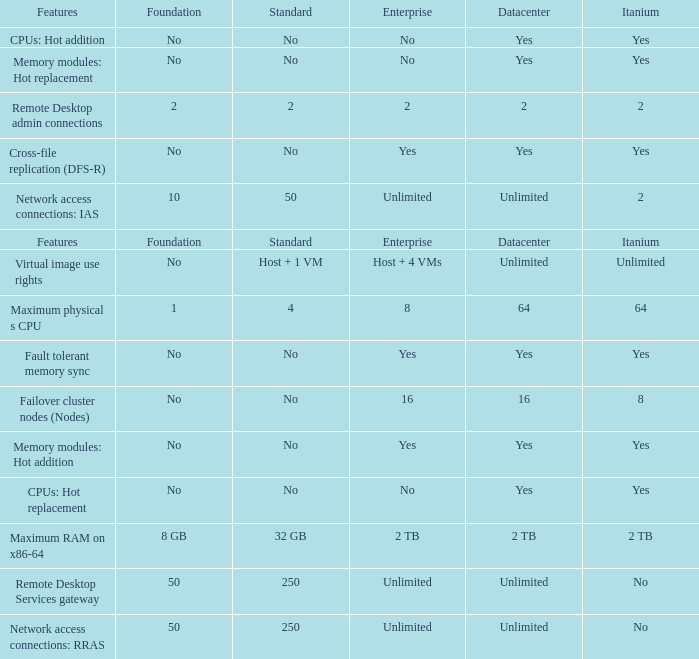What is the Enterprise for teh memory modules: hot replacement Feature that has a Datacenter of Yes? No. 